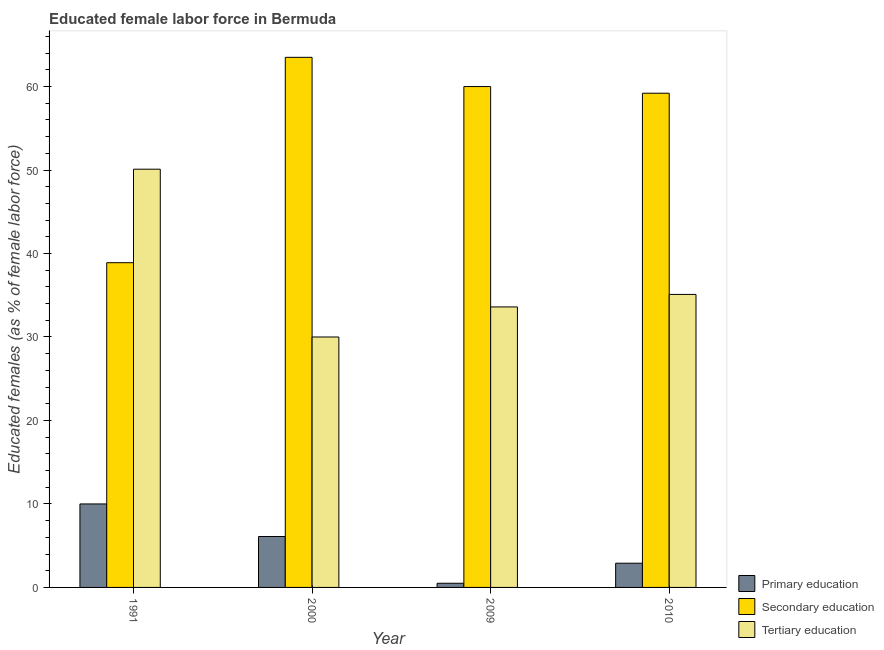Are the number of bars per tick equal to the number of legend labels?
Give a very brief answer. Yes. In how many cases, is the number of bars for a given year not equal to the number of legend labels?
Provide a succinct answer. 0. In which year was the percentage of female labor force who received secondary education maximum?
Ensure brevity in your answer.  2000. What is the total percentage of female labor force who received secondary education in the graph?
Make the answer very short. 221.6. What is the difference between the percentage of female labor force who received primary education in 2009 and that in 2010?
Offer a terse response. -2.4. What is the difference between the percentage of female labor force who received tertiary education in 1991 and the percentage of female labor force who received secondary education in 2009?
Provide a short and direct response. 16.5. What is the average percentage of female labor force who received primary education per year?
Make the answer very short. 4.88. What is the ratio of the percentage of female labor force who received primary education in 1991 to that in 2000?
Provide a succinct answer. 1.64. Is the percentage of female labor force who received secondary education in 2009 less than that in 2010?
Provide a succinct answer. No. What is the difference between the highest and the lowest percentage of female labor force who received secondary education?
Make the answer very short. 24.6. In how many years, is the percentage of female labor force who received secondary education greater than the average percentage of female labor force who received secondary education taken over all years?
Make the answer very short. 3. Is the sum of the percentage of female labor force who received primary education in 1991 and 2010 greater than the maximum percentage of female labor force who received secondary education across all years?
Your response must be concise. Yes. What does the 2nd bar from the left in 2010 represents?
Offer a very short reply. Secondary education. What does the 2nd bar from the right in 1991 represents?
Your answer should be very brief. Secondary education. How many years are there in the graph?
Keep it short and to the point. 4. What is the difference between two consecutive major ticks on the Y-axis?
Provide a succinct answer. 10. Are the values on the major ticks of Y-axis written in scientific E-notation?
Your answer should be very brief. No. Does the graph contain any zero values?
Ensure brevity in your answer.  No. Does the graph contain grids?
Your answer should be compact. No. Where does the legend appear in the graph?
Keep it short and to the point. Bottom right. How are the legend labels stacked?
Give a very brief answer. Vertical. What is the title of the graph?
Keep it short and to the point. Educated female labor force in Bermuda. Does "Agricultural raw materials" appear as one of the legend labels in the graph?
Provide a short and direct response. No. What is the label or title of the Y-axis?
Offer a terse response. Educated females (as % of female labor force). What is the Educated females (as % of female labor force) of Primary education in 1991?
Make the answer very short. 10. What is the Educated females (as % of female labor force) of Secondary education in 1991?
Offer a very short reply. 38.9. What is the Educated females (as % of female labor force) in Tertiary education in 1991?
Your answer should be very brief. 50.1. What is the Educated females (as % of female labor force) in Primary education in 2000?
Ensure brevity in your answer.  6.1. What is the Educated females (as % of female labor force) in Secondary education in 2000?
Your answer should be compact. 63.5. What is the Educated females (as % of female labor force) of Tertiary education in 2009?
Provide a succinct answer. 33.6. What is the Educated females (as % of female labor force) of Primary education in 2010?
Offer a terse response. 2.9. What is the Educated females (as % of female labor force) in Secondary education in 2010?
Keep it short and to the point. 59.2. What is the Educated females (as % of female labor force) in Tertiary education in 2010?
Your answer should be compact. 35.1. Across all years, what is the maximum Educated females (as % of female labor force) of Primary education?
Your answer should be very brief. 10. Across all years, what is the maximum Educated females (as % of female labor force) in Secondary education?
Provide a succinct answer. 63.5. Across all years, what is the maximum Educated females (as % of female labor force) of Tertiary education?
Ensure brevity in your answer.  50.1. Across all years, what is the minimum Educated females (as % of female labor force) of Primary education?
Give a very brief answer. 0.5. Across all years, what is the minimum Educated females (as % of female labor force) of Secondary education?
Keep it short and to the point. 38.9. What is the total Educated females (as % of female labor force) of Primary education in the graph?
Offer a terse response. 19.5. What is the total Educated females (as % of female labor force) in Secondary education in the graph?
Make the answer very short. 221.6. What is the total Educated females (as % of female labor force) of Tertiary education in the graph?
Give a very brief answer. 148.8. What is the difference between the Educated females (as % of female labor force) of Secondary education in 1991 and that in 2000?
Provide a short and direct response. -24.6. What is the difference between the Educated females (as % of female labor force) in Tertiary education in 1991 and that in 2000?
Offer a terse response. 20.1. What is the difference between the Educated females (as % of female labor force) of Secondary education in 1991 and that in 2009?
Give a very brief answer. -21.1. What is the difference between the Educated females (as % of female labor force) of Tertiary education in 1991 and that in 2009?
Offer a terse response. 16.5. What is the difference between the Educated females (as % of female labor force) of Primary education in 1991 and that in 2010?
Offer a very short reply. 7.1. What is the difference between the Educated females (as % of female labor force) in Secondary education in 1991 and that in 2010?
Your answer should be compact. -20.3. What is the difference between the Educated females (as % of female labor force) in Tertiary education in 1991 and that in 2010?
Make the answer very short. 15. What is the difference between the Educated females (as % of female labor force) in Primary education in 2000 and that in 2009?
Ensure brevity in your answer.  5.6. What is the difference between the Educated females (as % of female labor force) in Tertiary education in 2000 and that in 2009?
Ensure brevity in your answer.  -3.6. What is the difference between the Educated females (as % of female labor force) in Primary education in 2000 and that in 2010?
Give a very brief answer. 3.2. What is the difference between the Educated females (as % of female labor force) in Tertiary education in 2000 and that in 2010?
Make the answer very short. -5.1. What is the difference between the Educated females (as % of female labor force) in Secondary education in 2009 and that in 2010?
Provide a succinct answer. 0.8. What is the difference between the Educated females (as % of female labor force) of Tertiary education in 2009 and that in 2010?
Offer a terse response. -1.5. What is the difference between the Educated females (as % of female labor force) in Primary education in 1991 and the Educated females (as % of female labor force) in Secondary education in 2000?
Your answer should be compact. -53.5. What is the difference between the Educated females (as % of female labor force) in Primary education in 1991 and the Educated females (as % of female labor force) in Tertiary education in 2000?
Offer a terse response. -20. What is the difference between the Educated females (as % of female labor force) in Primary education in 1991 and the Educated females (as % of female labor force) in Secondary education in 2009?
Ensure brevity in your answer.  -50. What is the difference between the Educated females (as % of female labor force) of Primary education in 1991 and the Educated females (as % of female labor force) of Tertiary education in 2009?
Keep it short and to the point. -23.6. What is the difference between the Educated females (as % of female labor force) in Primary education in 1991 and the Educated females (as % of female labor force) in Secondary education in 2010?
Ensure brevity in your answer.  -49.2. What is the difference between the Educated females (as % of female labor force) in Primary education in 1991 and the Educated females (as % of female labor force) in Tertiary education in 2010?
Ensure brevity in your answer.  -25.1. What is the difference between the Educated females (as % of female labor force) of Primary education in 2000 and the Educated females (as % of female labor force) of Secondary education in 2009?
Keep it short and to the point. -53.9. What is the difference between the Educated females (as % of female labor force) in Primary education in 2000 and the Educated females (as % of female labor force) in Tertiary education in 2009?
Provide a succinct answer. -27.5. What is the difference between the Educated females (as % of female labor force) of Secondary education in 2000 and the Educated females (as % of female labor force) of Tertiary education in 2009?
Give a very brief answer. 29.9. What is the difference between the Educated females (as % of female labor force) of Primary education in 2000 and the Educated females (as % of female labor force) of Secondary education in 2010?
Your response must be concise. -53.1. What is the difference between the Educated females (as % of female labor force) in Primary education in 2000 and the Educated females (as % of female labor force) in Tertiary education in 2010?
Keep it short and to the point. -29. What is the difference between the Educated females (as % of female labor force) of Secondary education in 2000 and the Educated females (as % of female labor force) of Tertiary education in 2010?
Give a very brief answer. 28.4. What is the difference between the Educated females (as % of female labor force) of Primary education in 2009 and the Educated females (as % of female labor force) of Secondary education in 2010?
Make the answer very short. -58.7. What is the difference between the Educated females (as % of female labor force) in Primary education in 2009 and the Educated females (as % of female labor force) in Tertiary education in 2010?
Your response must be concise. -34.6. What is the difference between the Educated females (as % of female labor force) in Secondary education in 2009 and the Educated females (as % of female labor force) in Tertiary education in 2010?
Give a very brief answer. 24.9. What is the average Educated females (as % of female labor force) in Primary education per year?
Offer a very short reply. 4.88. What is the average Educated females (as % of female labor force) in Secondary education per year?
Provide a short and direct response. 55.4. What is the average Educated females (as % of female labor force) of Tertiary education per year?
Ensure brevity in your answer.  37.2. In the year 1991, what is the difference between the Educated females (as % of female labor force) in Primary education and Educated females (as % of female labor force) in Secondary education?
Offer a very short reply. -28.9. In the year 1991, what is the difference between the Educated females (as % of female labor force) in Primary education and Educated females (as % of female labor force) in Tertiary education?
Provide a succinct answer. -40.1. In the year 2000, what is the difference between the Educated females (as % of female labor force) in Primary education and Educated females (as % of female labor force) in Secondary education?
Offer a very short reply. -57.4. In the year 2000, what is the difference between the Educated females (as % of female labor force) of Primary education and Educated females (as % of female labor force) of Tertiary education?
Your response must be concise. -23.9. In the year 2000, what is the difference between the Educated females (as % of female labor force) in Secondary education and Educated females (as % of female labor force) in Tertiary education?
Keep it short and to the point. 33.5. In the year 2009, what is the difference between the Educated females (as % of female labor force) of Primary education and Educated females (as % of female labor force) of Secondary education?
Your response must be concise. -59.5. In the year 2009, what is the difference between the Educated females (as % of female labor force) in Primary education and Educated females (as % of female labor force) in Tertiary education?
Provide a succinct answer. -33.1. In the year 2009, what is the difference between the Educated females (as % of female labor force) of Secondary education and Educated females (as % of female labor force) of Tertiary education?
Give a very brief answer. 26.4. In the year 2010, what is the difference between the Educated females (as % of female labor force) in Primary education and Educated females (as % of female labor force) in Secondary education?
Make the answer very short. -56.3. In the year 2010, what is the difference between the Educated females (as % of female labor force) of Primary education and Educated females (as % of female labor force) of Tertiary education?
Ensure brevity in your answer.  -32.2. In the year 2010, what is the difference between the Educated females (as % of female labor force) in Secondary education and Educated females (as % of female labor force) in Tertiary education?
Offer a very short reply. 24.1. What is the ratio of the Educated females (as % of female labor force) of Primary education in 1991 to that in 2000?
Provide a short and direct response. 1.64. What is the ratio of the Educated females (as % of female labor force) of Secondary education in 1991 to that in 2000?
Offer a very short reply. 0.61. What is the ratio of the Educated females (as % of female labor force) in Tertiary education in 1991 to that in 2000?
Ensure brevity in your answer.  1.67. What is the ratio of the Educated females (as % of female labor force) of Secondary education in 1991 to that in 2009?
Give a very brief answer. 0.65. What is the ratio of the Educated females (as % of female labor force) of Tertiary education in 1991 to that in 2009?
Your response must be concise. 1.49. What is the ratio of the Educated females (as % of female labor force) of Primary education in 1991 to that in 2010?
Your response must be concise. 3.45. What is the ratio of the Educated females (as % of female labor force) in Secondary education in 1991 to that in 2010?
Your answer should be compact. 0.66. What is the ratio of the Educated females (as % of female labor force) of Tertiary education in 1991 to that in 2010?
Offer a very short reply. 1.43. What is the ratio of the Educated females (as % of female labor force) of Primary education in 2000 to that in 2009?
Provide a short and direct response. 12.2. What is the ratio of the Educated females (as % of female labor force) of Secondary education in 2000 to that in 2009?
Ensure brevity in your answer.  1.06. What is the ratio of the Educated females (as % of female labor force) of Tertiary education in 2000 to that in 2009?
Your answer should be very brief. 0.89. What is the ratio of the Educated females (as % of female labor force) in Primary education in 2000 to that in 2010?
Your response must be concise. 2.1. What is the ratio of the Educated females (as % of female labor force) in Secondary education in 2000 to that in 2010?
Ensure brevity in your answer.  1.07. What is the ratio of the Educated females (as % of female labor force) in Tertiary education in 2000 to that in 2010?
Your response must be concise. 0.85. What is the ratio of the Educated females (as % of female labor force) in Primary education in 2009 to that in 2010?
Make the answer very short. 0.17. What is the ratio of the Educated females (as % of female labor force) in Secondary education in 2009 to that in 2010?
Keep it short and to the point. 1.01. What is the ratio of the Educated females (as % of female labor force) in Tertiary education in 2009 to that in 2010?
Keep it short and to the point. 0.96. What is the difference between the highest and the second highest Educated females (as % of female labor force) in Primary education?
Your answer should be compact. 3.9. What is the difference between the highest and the second highest Educated females (as % of female labor force) in Tertiary education?
Keep it short and to the point. 15. What is the difference between the highest and the lowest Educated females (as % of female labor force) in Secondary education?
Ensure brevity in your answer.  24.6. What is the difference between the highest and the lowest Educated females (as % of female labor force) in Tertiary education?
Give a very brief answer. 20.1. 